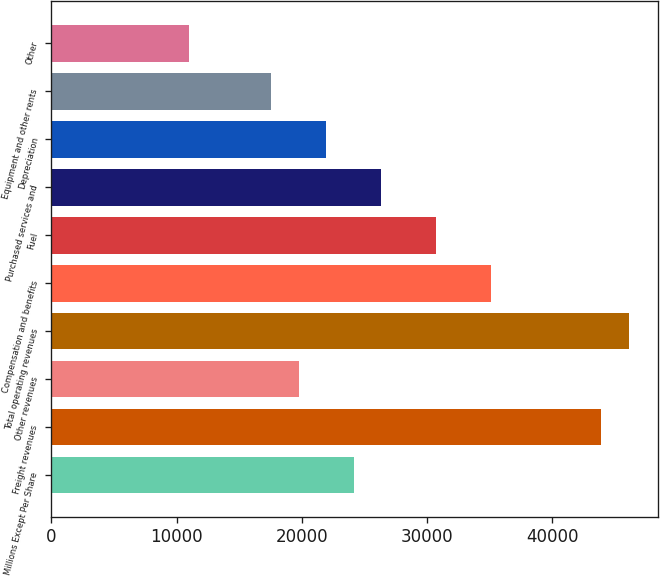Convert chart. <chart><loc_0><loc_0><loc_500><loc_500><bar_chart><fcel>Millions Except Per Share<fcel>Freight revenues<fcel>Other revenues<fcel>Total operating revenues<fcel>Compensation and benefits<fcel>Fuel<fcel>Purchased services and<fcel>Depreciation<fcel>Equipment and other rents<fcel>Other<nl><fcel>24159.1<fcel>43924.5<fcel>19766.8<fcel>46120.6<fcel>35139.9<fcel>30747.6<fcel>26355.3<fcel>21963<fcel>17570.7<fcel>10982.2<nl></chart> 